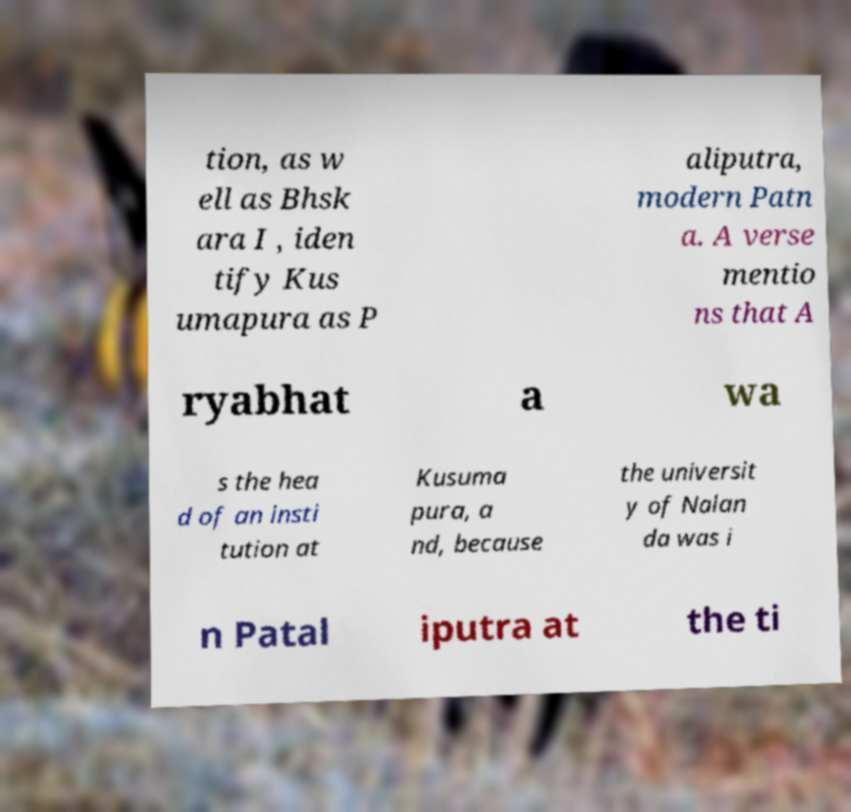Could you assist in decoding the text presented in this image and type it out clearly? tion, as w ell as Bhsk ara I , iden tify Kus umapura as P aliputra, modern Patn a. A verse mentio ns that A ryabhat a wa s the hea d of an insti tution at Kusuma pura, a nd, because the universit y of Nalan da was i n Patal iputra at the ti 